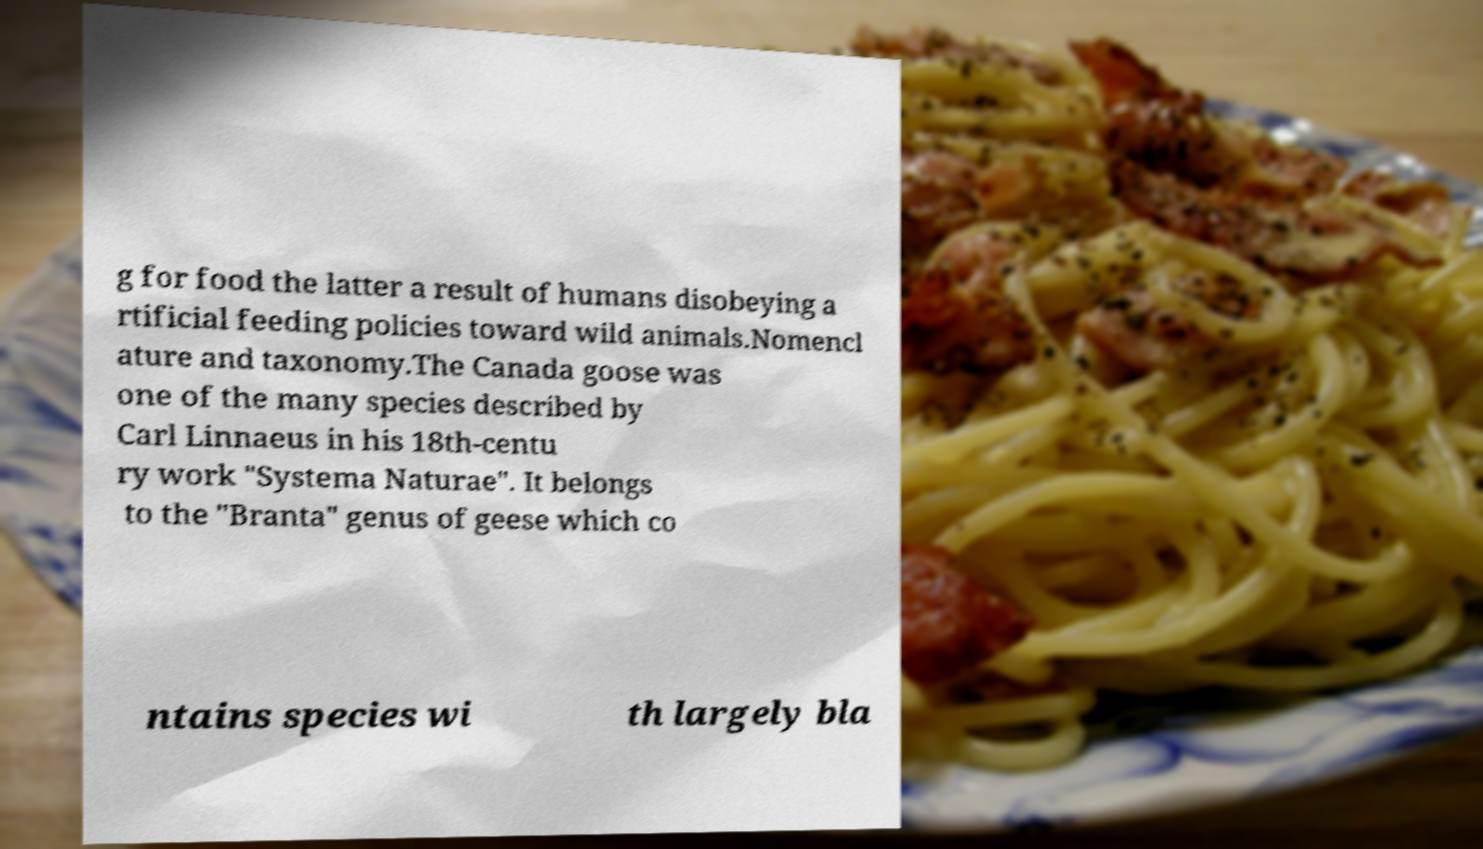Please identify and transcribe the text found in this image. g for food the latter a result of humans disobeying a rtificial feeding policies toward wild animals.Nomencl ature and taxonomy.The Canada goose was one of the many species described by Carl Linnaeus in his 18th-centu ry work "Systema Naturae". It belongs to the "Branta" genus of geese which co ntains species wi th largely bla 